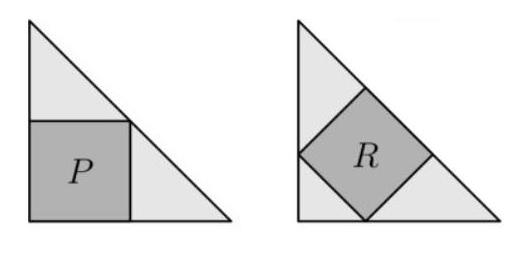If we wanted to draw a third square that is congruent to square R in one of the unshaded regions of the same triangle, is that possible, and how? It is indeed possible. To draw a third square congruent to square R in the unshaded region of the triangle containing R, you would place one corner of the new square at the right angle vertex of the triangle, and have the sides of this square also be at a 45-degree angle to the triangle's sides, much like square R. This new square, like R, would have its sides equal to the hypotenuse of square P divided by the square root of 2. As there's symmetrical space unoccupied by square R, the second congruent square would fit perfectly in the other half of the triangle. 